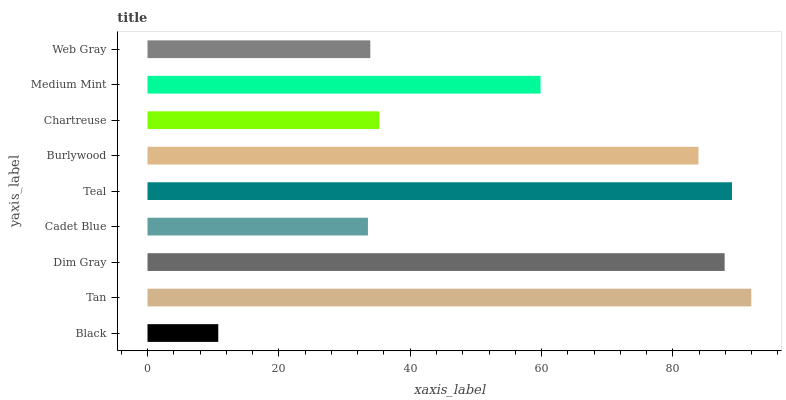Is Black the minimum?
Answer yes or no. Yes. Is Tan the maximum?
Answer yes or no. Yes. Is Dim Gray the minimum?
Answer yes or no. No. Is Dim Gray the maximum?
Answer yes or no. No. Is Tan greater than Dim Gray?
Answer yes or no. Yes. Is Dim Gray less than Tan?
Answer yes or no. Yes. Is Dim Gray greater than Tan?
Answer yes or no. No. Is Tan less than Dim Gray?
Answer yes or no. No. Is Medium Mint the high median?
Answer yes or no. Yes. Is Medium Mint the low median?
Answer yes or no. Yes. Is Black the high median?
Answer yes or no. No. Is Black the low median?
Answer yes or no. No. 